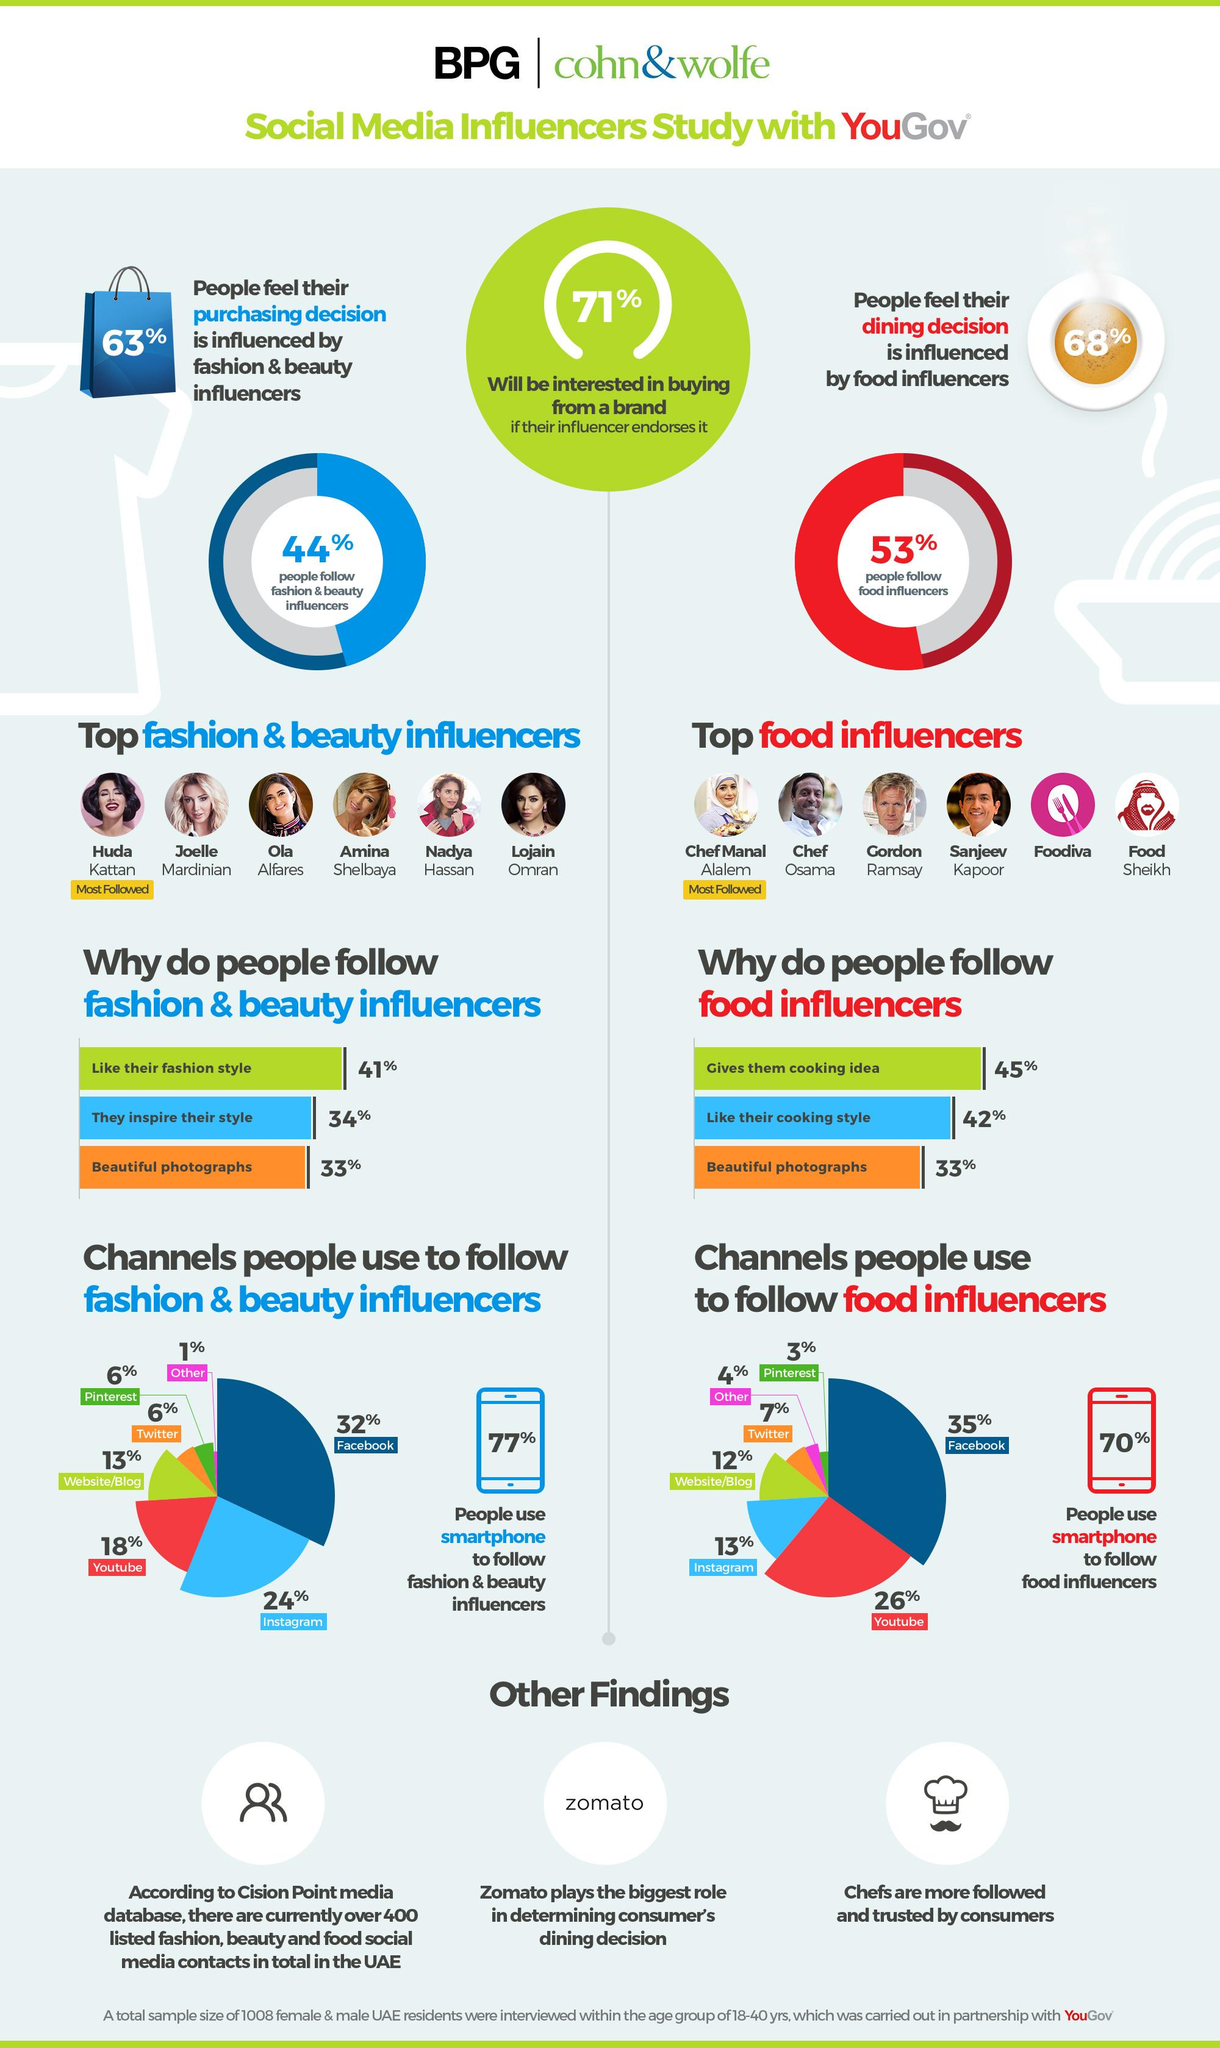List a handful of essential elements in this visual. According to the survey, a significant majority of people, or 77%, use a smartphone to follow fashion and beauty influencers. According to the survey, 26% of respondents reported using YouTube to follow food influencers. According to a survey, approximately 33% of UAE residents in the age group of 18-40 years follow fashion and beauty influencers because of their beautiful photographs. According to a survey, 42% of UAE residents in the age group of 18-40 years follow food influencers due to their cooking style. According to the survey, the majority of respondents use Facebook to follow food influencers. 